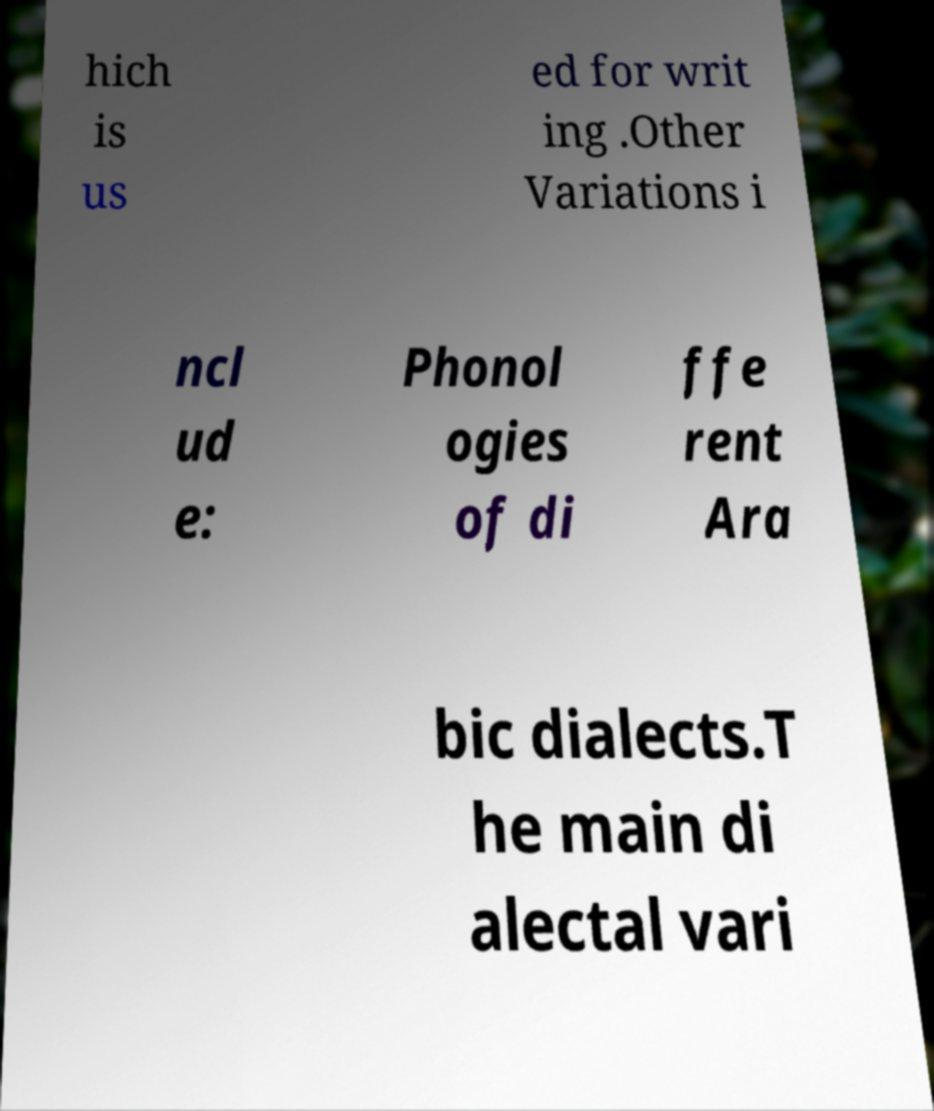Can you accurately transcribe the text from the provided image for me? hich is us ed for writ ing .Other Variations i ncl ud e: Phonol ogies of di ffe rent Ara bic dialects.T he main di alectal vari 